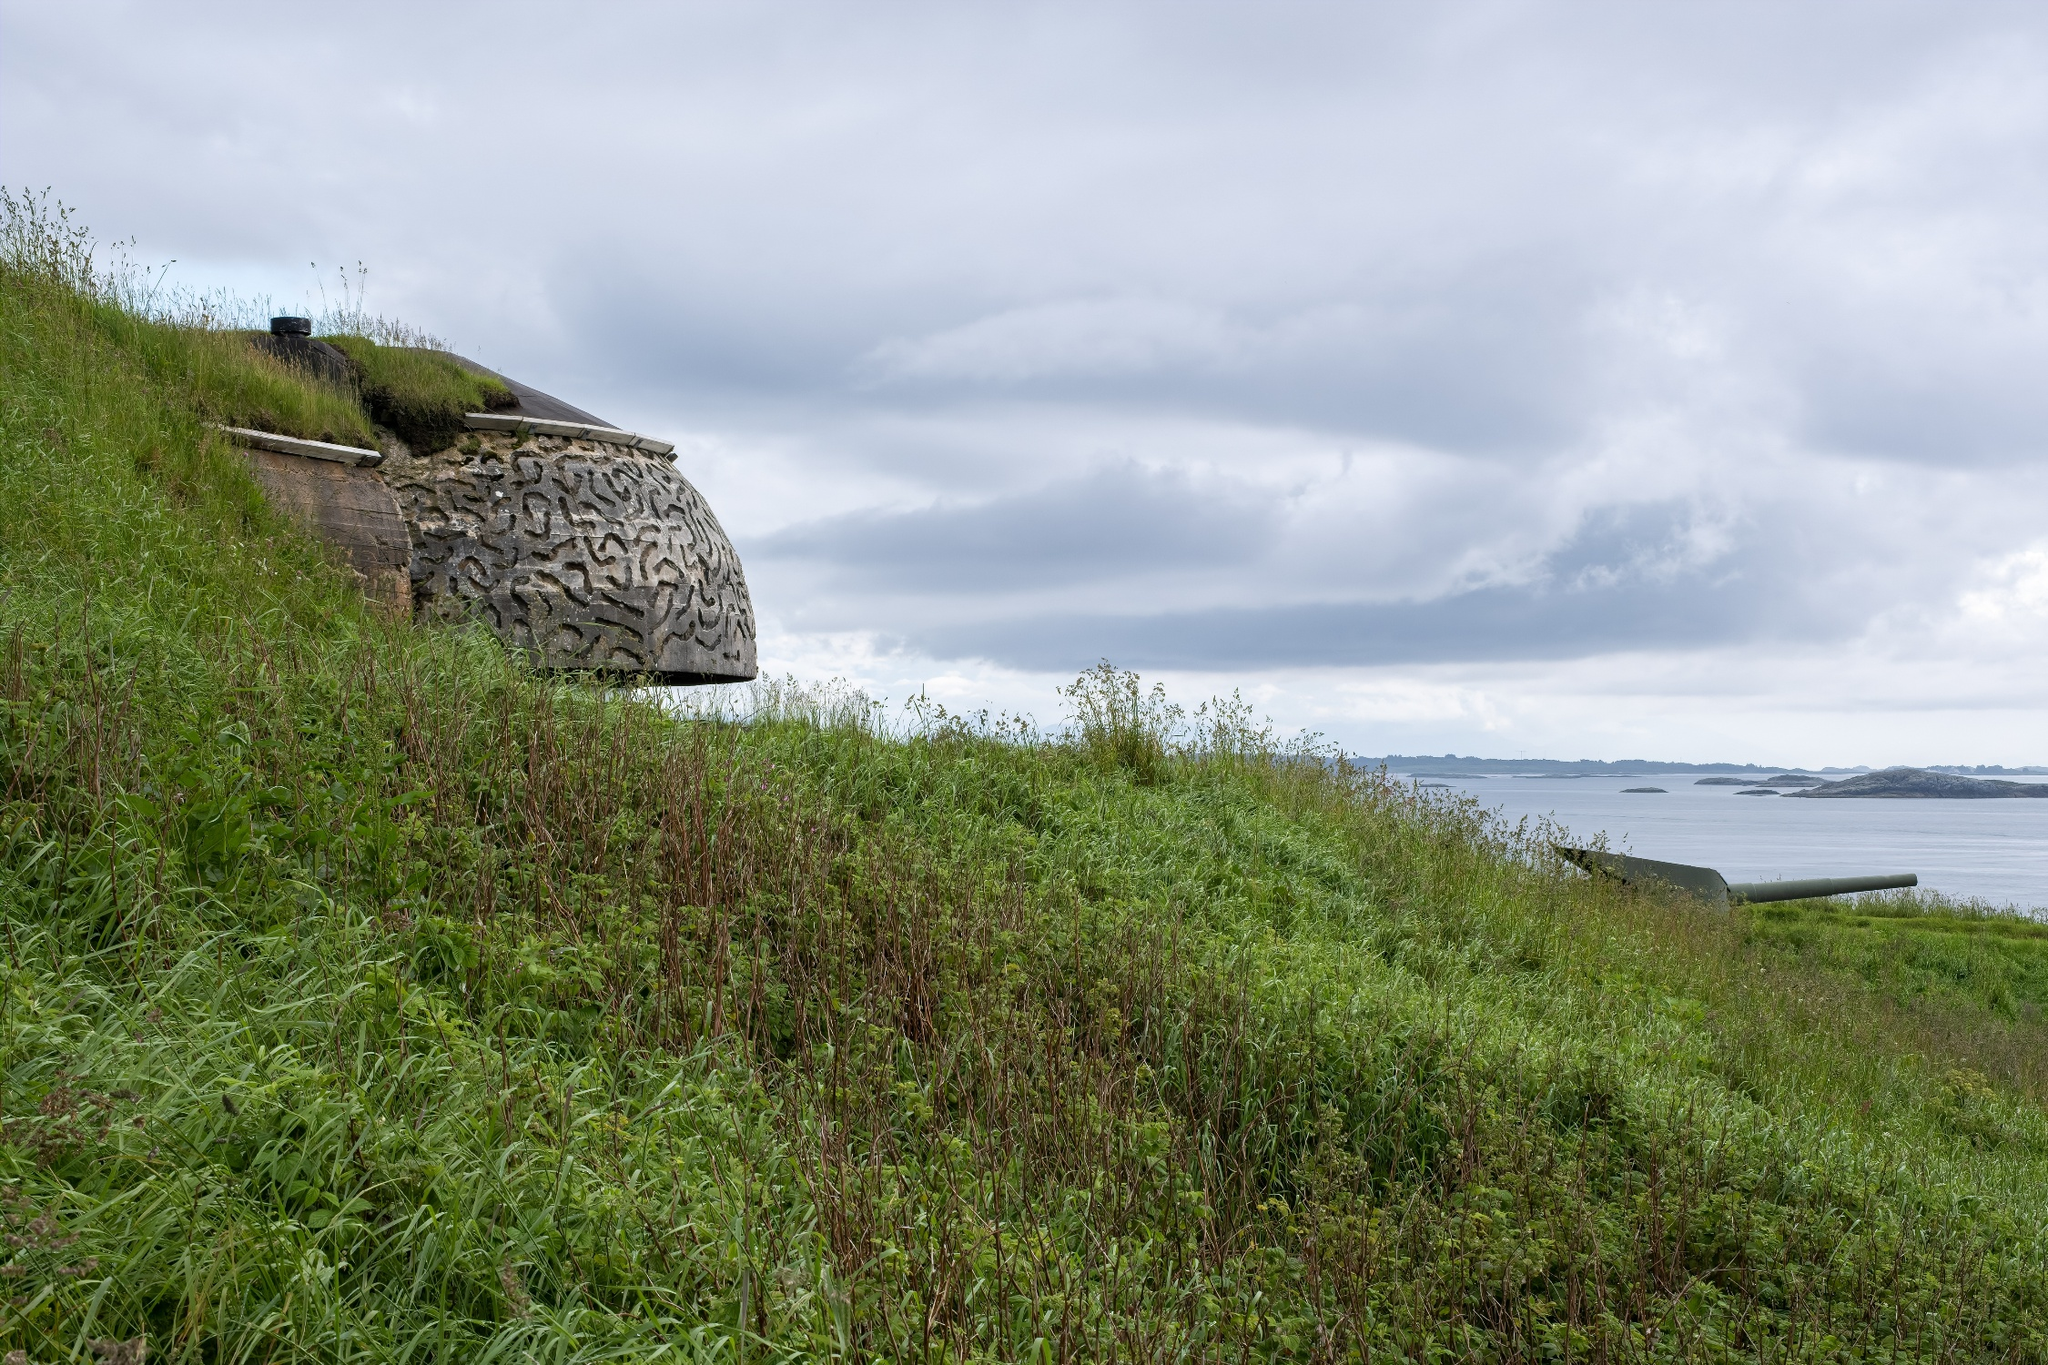Can you narrate a story associated with this image? In a distant past, this stone bunker on the hillside was part of a coastal defense system, standing vigilant against potential invaders. Crafted meticulously, the intricate patterns on its surface were etched by skilled artisans, leaving a legacy of their craftsmanship. As years passed, the bunker became a remnant of history, gradually embraced by nature. The hillside flourished with greenery, the grass and shrubs encroaching, yet respectfully cohabiting with the old structure. The ocean, once a potential battleground, now stretches out calmly, symbolizing peace and tranquility. Above, the ever-changing clouds in the sky bear silent witness to the passage of time, encapsulating the enduring spirit of the place. If this place could speak, what stories would it tell? If this place could speak, it would narrate tales of resilience and transformation. It would recount the days when the bunker was a symbol of strength and vigilance, safeguarding the coast against unseen threats. Soldiers once stationed here would scan the horizon, eyes sharp and hearts steeled. The place would also share stories of quiet moments under the open sky, where dreams of peace were dreamt even amidst the chaos of readiness. As decades passed, the place witnessed a transformation - the stone bunker slowly wearing the cloak of nature, as grass and shrubs claimed the land. The tales of erstwhile defenses would merge with serene whispers of the ocean and rustling of the leaves, creating a symphony of history merging with tranquility. Today, this place stands as a silent storyteller, reminding us of the past while embodying the peace of the present. 